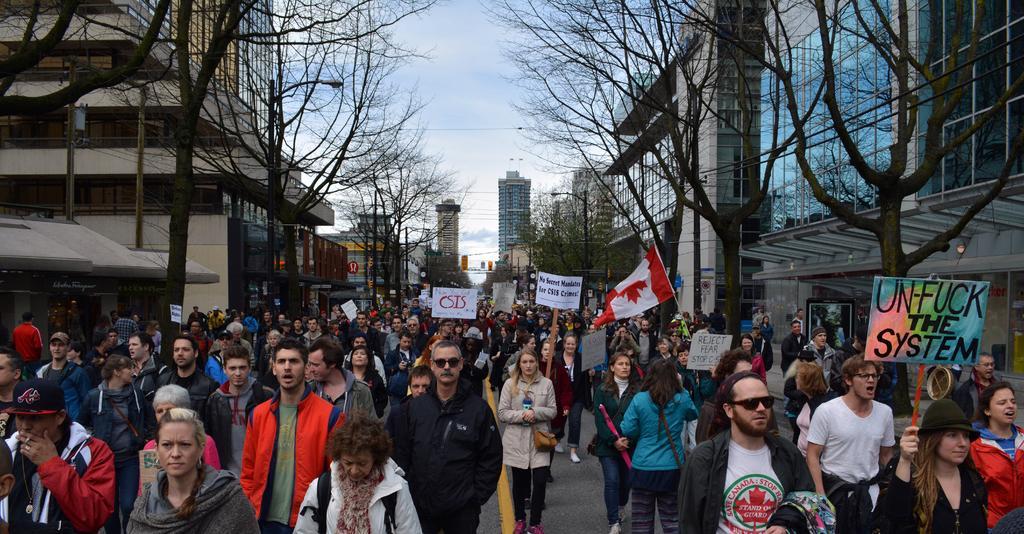In one or two sentences, can you explain what this image depicts? In this picture I can see there is a crowd of people walking and they are holding banners, there are trees at left and right sides of the road and there are buildings and the sky is clear. 